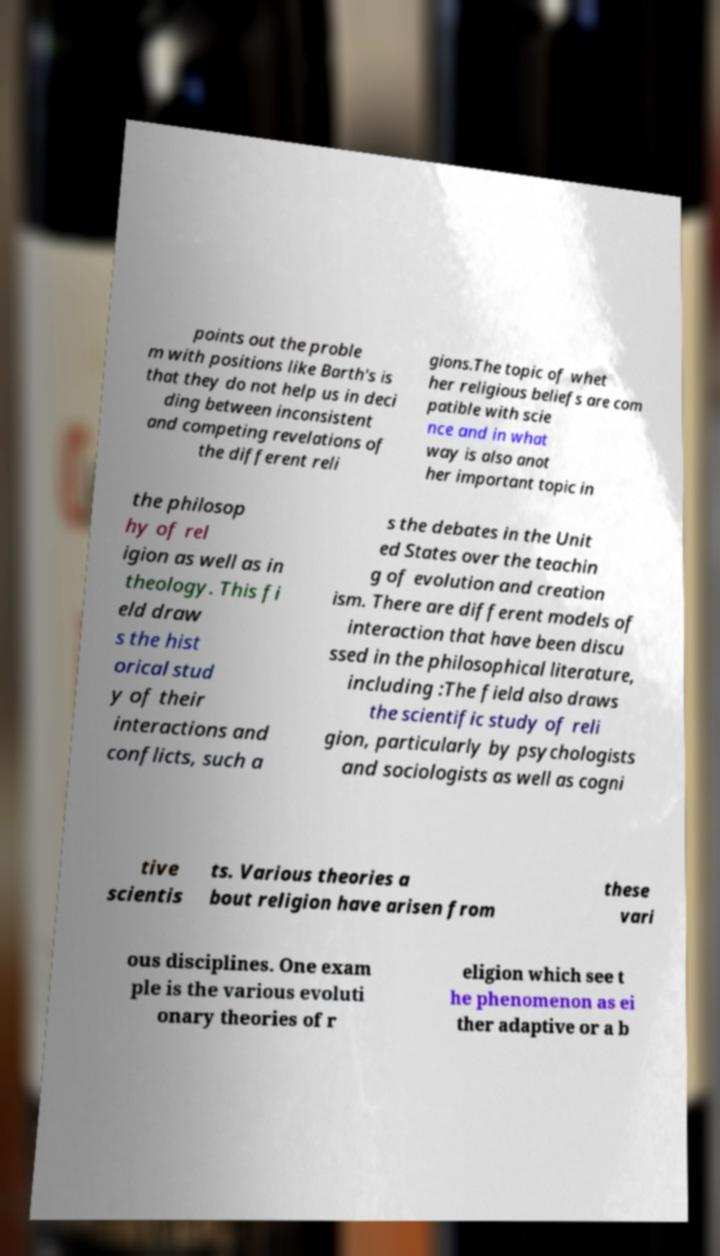For documentation purposes, I need the text within this image transcribed. Could you provide that? points out the proble m with positions like Barth's is that they do not help us in deci ding between inconsistent and competing revelations of the different reli gions.The topic of whet her religious beliefs are com patible with scie nce and in what way is also anot her important topic in the philosop hy of rel igion as well as in theology. This fi eld draw s the hist orical stud y of their interactions and conflicts, such a s the debates in the Unit ed States over the teachin g of evolution and creation ism. There are different models of interaction that have been discu ssed in the philosophical literature, including :The field also draws the scientific study of reli gion, particularly by psychologists and sociologists as well as cogni tive scientis ts. Various theories a bout religion have arisen from these vari ous disciplines. One exam ple is the various evoluti onary theories of r eligion which see t he phenomenon as ei ther adaptive or a b 